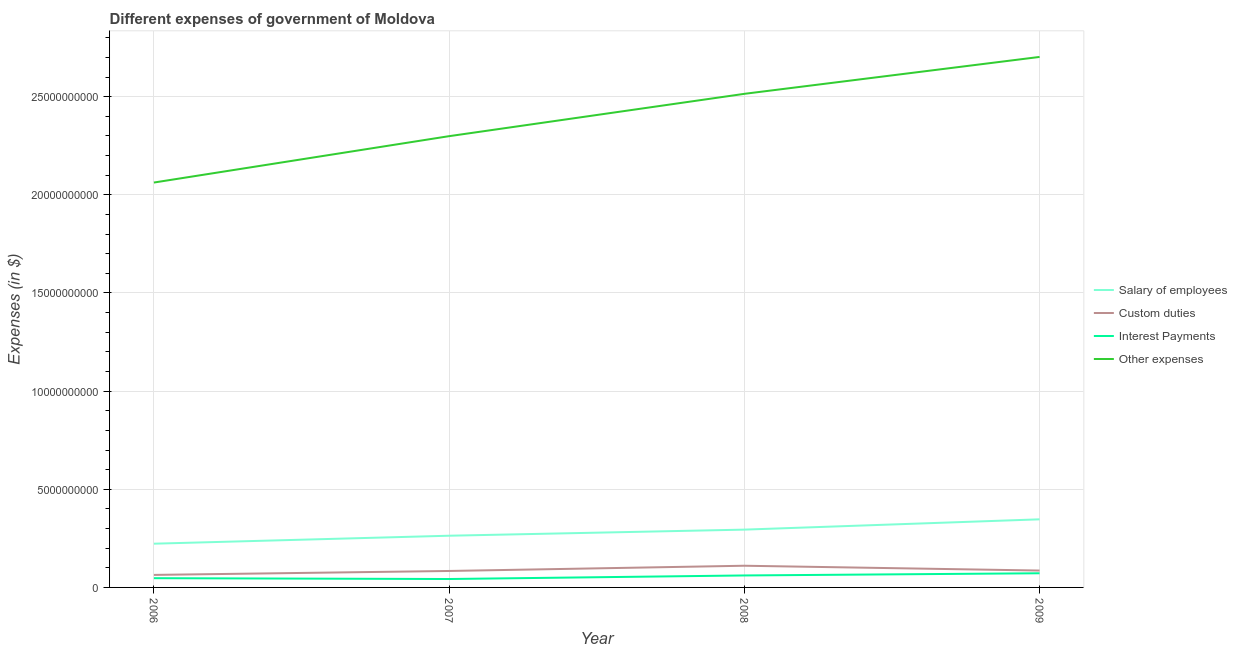How many different coloured lines are there?
Provide a short and direct response. 4. What is the amount spent on custom duties in 2008?
Provide a succinct answer. 1.10e+09. Across all years, what is the maximum amount spent on custom duties?
Make the answer very short. 1.10e+09. Across all years, what is the minimum amount spent on interest payments?
Ensure brevity in your answer.  4.29e+08. What is the total amount spent on custom duties in the graph?
Provide a succinct answer. 3.44e+09. What is the difference between the amount spent on salary of employees in 2006 and that in 2008?
Provide a succinct answer. -7.17e+08. What is the difference between the amount spent on salary of employees in 2006 and the amount spent on other expenses in 2008?
Your answer should be compact. -2.29e+1. What is the average amount spent on other expenses per year?
Provide a short and direct response. 2.39e+1. In the year 2006, what is the difference between the amount spent on other expenses and amount spent on salary of employees?
Provide a succinct answer. 1.84e+1. What is the ratio of the amount spent on custom duties in 2007 to that in 2009?
Provide a short and direct response. 0.97. Is the difference between the amount spent on other expenses in 2006 and 2008 greater than the difference between the amount spent on custom duties in 2006 and 2008?
Your answer should be very brief. No. What is the difference between the highest and the second highest amount spent on other expenses?
Your response must be concise. 1.88e+09. What is the difference between the highest and the lowest amount spent on custom duties?
Give a very brief answer. 4.68e+08. In how many years, is the amount spent on salary of employees greater than the average amount spent on salary of employees taken over all years?
Make the answer very short. 2. Is the sum of the amount spent on other expenses in 2006 and 2007 greater than the maximum amount spent on interest payments across all years?
Ensure brevity in your answer.  Yes. Is it the case that in every year, the sum of the amount spent on other expenses and amount spent on salary of employees is greater than the sum of amount spent on custom duties and amount spent on interest payments?
Provide a short and direct response. Yes. Is it the case that in every year, the sum of the amount spent on salary of employees and amount spent on custom duties is greater than the amount spent on interest payments?
Provide a succinct answer. Yes. Is the amount spent on salary of employees strictly greater than the amount spent on interest payments over the years?
Ensure brevity in your answer.  Yes. Is the amount spent on interest payments strictly less than the amount spent on custom duties over the years?
Offer a very short reply. Yes. What is the difference between two consecutive major ticks on the Y-axis?
Offer a terse response. 5.00e+09. Does the graph contain any zero values?
Offer a terse response. No. How are the legend labels stacked?
Keep it short and to the point. Vertical. What is the title of the graph?
Your answer should be compact. Different expenses of government of Moldova. What is the label or title of the X-axis?
Provide a succinct answer. Year. What is the label or title of the Y-axis?
Offer a very short reply. Expenses (in $). What is the Expenses (in $) in Salary of employees in 2006?
Your response must be concise. 2.23e+09. What is the Expenses (in $) in Custom duties in 2006?
Your answer should be compact. 6.37e+08. What is the Expenses (in $) in Interest Payments in 2006?
Ensure brevity in your answer.  4.70e+08. What is the Expenses (in $) in Other expenses in 2006?
Ensure brevity in your answer.  2.06e+1. What is the Expenses (in $) of Salary of employees in 2007?
Your response must be concise. 2.63e+09. What is the Expenses (in $) of Custom duties in 2007?
Keep it short and to the point. 8.38e+08. What is the Expenses (in $) in Interest Payments in 2007?
Your answer should be compact. 4.29e+08. What is the Expenses (in $) of Other expenses in 2007?
Offer a terse response. 2.30e+1. What is the Expenses (in $) in Salary of employees in 2008?
Ensure brevity in your answer.  2.94e+09. What is the Expenses (in $) in Custom duties in 2008?
Give a very brief answer. 1.10e+09. What is the Expenses (in $) in Interest Payments in 2008?
Your answer should be compact. 6.10e+08. What is the Expenses (in $) of Other expenses in 2008?
Offer a very short reply. 2.51e+1. What is the Expenses (in $) of Salary of employees in 2009?
Provide a short and direct response. 3.47e+09. What is the Expenses (in $) of Custom duties in 2009?
Provide a succinct answer. 8.60e+08. What is the Expenses (in $) in Interest Payments in 2009?
Provide a short and direct response. 7.22e+08. What is the Expenses (in $) of Other expenses in 2009?
Provide a succinct answer. 2.70e+1. Across all years, what is the maximum Expenses (in $) of Salary of employees?
Your answer should be compact. 3.47e+09. Across all years, what is the maximum Expenses (in $) in Custom duties?
Provide a short and direct response. 1.10e+09. Across all years, what is the maximum Expenses (in $) of Interest Payments?
Your answer should be very brief. 7.22e+08. Across all years, what is the maximum Expenses (in $) in Other expenses?
Offer a terse response. 2.70e+1. Across all years, what is the minimum Expenses (in $) of Salary of employees?
Offer a very short reply. 2.23e+09. Across all years, what is the minimum Expenses (in $) in Custom duties?
Your answer should be compact. 6.37e+08. Across all years, what is the minimum Expenses (in $) of Interest Payments?
Offer a terse response. 4.29e+08. Across all years, what is the minimum Expenses (in $) of Other expenses?
Your response must be concise. 2.06e+1. What is the total Expenses (in $) of Salary of employees in the graph?
Your response must be concise. 1.13e+1. What is the total Expenses (in $) in Custom duties in the graph?
Offer a terse response. 3.44e+09. What is the total Expenses (in $) of Interest Payments in the graph?
Give a very brief answer. 2.23e+09. What is the total Expenses (in $) of Other expenses in the graph?
Ensure brevity in your answer.  9.58e+1. What is the difference between the Expenses (in $) of Salary of employees in 2006 and that in 2007?
Give a very brief answer. -4.07e+08. What is the difference between the Expenses (in $) in Custom duties in 2006 and that in 2007?
Your response must be concise. -2.01e+08. What is the difference between the Expenses (in $) in Interest Payments in 2006 and that in 2007?
Provide a succinct answer. 4.19e+07. What is the difference between the Expenses (in $) in Other expenses in 2006 and that in 2007?
Your answer should be compact. -2.36e+09. What is the difference between the Expenses (in $) in Salary of employees in 2006 and that in 2008?
Ensure brevity in your answer.  -7.17e+08. What is the difference between the Expenses (in $) in Custom duties in 2006 and that in 2008?
Ensure brevity in your answer.  -4.68e+08. What is the difference between the Expenses (in $) of Interest Payments in 2006 and that in 2008?
Offer a terse response. -1.39e+08. What is the difference between the Expenses (in $) of Other expenses in 2006 and that in 2008?
Provide a short and direct response. -4.52e+09. What is the difference between the Expenses (in $) in Salary of employees in 2006 and that in 2009?
Provide a succinct answer. -1.24e+09. What is the difference between the Expenses (in $) in Custom duties in 2006 and that in 2009?
Offer a very short reply. -2.23e+08. What is the difference between the Expenses (in $) of Interest Payments in 2006 and that in 2009?
Provide a succinct answer. -2.51e+08. What is the difference between the Expenses (in $) in Other expenses in 2006 and that in 2009?
Keep it short and to the point. -6.40e+09. What is the difference between the Expenses (in $) of Salary of employees in 2007 and that in 2008?
Your answer should be compact. -3.10e+08. What is the difference between the Expenses (in $) in Custom duties in 2007 and that in 2008?
Your answer should be compact. -2.66e+08. What is the difference between the Expenses (in $) in Interest Payments in 2007 and that in 2008?
Ensure brevity in your answer.  -1.81e+08. What is the difference between the Expenses (in $) of Other expenses in 2007 and that in 2008?
Your response must be concise. -2.16e+09. What is the difference between the Expenses (in $) in Salary of employees in 2007 and that in 2009?
Keep it short and to the point. -8.34e+08. What is the difference between the Expenses (in $) in Custom duties in 2007 and that in 2009?
Ensure brevity in your answer.  -2.17e+07. What is the difference between the Expenses (in $) of Interest Payments in 2007 and that in 2009?
Give a very brief answer. -2.93e+08. What is the difference between the Expenses (in $) in Other expenses in 2007 and that in 2009?
Make the answer very short. -4.04e+09. What is the difference between the Expenses (in $) of Salary of employees in 2008 and that in 2009?
Offer a very short reply. -5.25e+08. What is the difference between the Expenses (in $) in Custom duties in 2008 and that in 2009?
Offer a very short reply. 2.45e+08. What is the difference between the Expenses (in $) of Interest Payments in 2008 and that in 2009?
Make the answer very short. -1.12e+08. What is the difference between the Expenses (in $) of Other expenses in 2008 and that in 2009?
Make the answer very short. -1.88e+09. What is the difference between the Expenses (in $) of Salary of employees in 2006 and the Expenses (in $) of Custom duties in 2007?
Offer a very short reply. 1.39e+09. What is the difference between the Expenses (in $) in Salary of employees in 2006 and the Expenses (in $) in Interest Payments in 2007?
Provide a short and direct response. 1.80e+09. What is the difference between the Expenses (in $) of Salary of employees in 2006 and the Expenses (in $) of Other expenses in 2007?
Offer a terse response. -2.08e+1. What is the difference between the Expenses (in $) of Custom duties in 2006 and the Expenses (in $) of Interest Payments in 2007?
Your answer should be very brief. 2.09e+08. What is the difference between the Expenses (in $) of Custom duties in 2006 and the Expenses (in $) of Other expenses in 2007?
Keep it short and to the point. -2.24e+1. What is the difference between the Expenses (in $) of Interest Payments in 2006 and the Expenses (in $) of Other expenses in 2007?
Your response must be concise. -2.25e+1. What is the difference between the Expenses (in $) of Salary of employees in 2006 and the Expenses (in $) of Custom duties in 2008?
Your answer should be very brief. 1.12e+09. What is the difference between the Expenses (in $) of Salary of employees in 2006 and the Expenses (in $) of Interest Payments in 2008?
Provide a succinct answer. 1.62e+09. What is the difference between the Expenses (in $) in Salary of employees in 2006 and the Expenses (in $) in Other expenses in 2008?
Offer a terse response. -2.29e+1. What is the difference between the Expenses (in $) of Custom duties in 2006 and the Expenses (in $) of Interest Payments in 2008?
Give a very brief answer. 2.76e+07. What is the difference between the Expenses (in $) of Custom duties in 2006 and the Expenses (in $) of Other expenses in 2008?
Make the answer very short. -2.45e+1. What is the difference between the Expenses (in $) of Interest Payments in 2006 and the Expenses (in $) of Other expenses in 2008?
Make the answer very short. -2.47e+1. What is the difference between the Expenses (in $) of Salary of employees in 2006 and the Expenses (in $) of Custom duties in 2009?
Keep it short and to the point. 1.37e+09. What is the difference between the Expenses (in $) of Salary of employees in 2006 and the Expenses (in $) of Interest Payments in 2009?
Provide a short and direct response. 1.51e+09. What is the difference between the Expenses (in $) of Salary of employees in 2006 and the Expenses (in $) of Other expenses in 2009?
Your answer should be compact. -2.48e+1. What is the difference between the Expenses (in $) in Custom duties in 2006 and the Expenses (in $) in Interest Payments in 2009?
Provide a short and direct response. -8.42e+07. What is the difference between the Expenses (in $) of Custom duties in 2006 and the Expenses (in $) of Other expenses in 2009?
Keep it short and to the point. -2.64e+1. What is the difference between the Expenses (in $) in Interest Payments in 2006 and the Expenses (in $) in Other expenses in 2009?
Provide a succinct answer. -2.66e+1. What is the difference between the Expenses (in $) of Salary of employees in 2007 and the Expenses (in $) of Custom duties in 2008?
Keep it short and to the point. 1.53e+09. What is the difference between the Expenses (in $) in Salary of employees in 2007 and the Expenses (in $) in Interest Payments in 2008?
Ensure brevity in your answer.  2.02e+09. What is the difference between the Expenses (in $) in Salary of employees in 2007 and the Expenses (in $) in Other expenses in 2008?
Offer a very short reply. -2.25e+1. What is the difference between the Expenses (in $) of Custom duties in 2007 and the Expenses (in $) of Interest Payments in 2008?
Provide a succinct answer. 2.29e+08. What is the difference between the Expenses (in $) in Custom duties in 2007 and the Expenses (in $) in Other expenses in 2008?
Offer a very short reply. -2.43e+1. What is the difference between the Expenses (in $) of Interest Payments in 2007 and the Expenses (in $) of Other expenses in 2008?
Your response must be concise. -2.47e+1. What is the difference between the Expenses (in $) of Salary of employees in 2007 and the Expenses (in $) of Custom duties in 2009?
Your answer should be compact. 1.77e+09. What is the difference between the Expenses (in $) of Salary of employees in 2007 and the Expenses (in $) of Interest Payments in 2009?
Give a very brief answer. 1.91e+09. What is the difference between the Expenses (in $) of Salary of employees in 2007 and the Expenses (in $) of Other expenses in 2009?
Your response must be concise. -2.44e+1. What is the difference between the Expenses (in $) in Custom duties in 2007 and the Expenses (in $) in Interest Payments in 2009?
Ensure brevity in your answer.  1.17e+08. What is the difference between the Expenses (in $) in Custom duties in 2007 and the Expenses (in $) in Other expenses in 2009?
Give a very brief answer. -2.62e+1. What is the difference between the Expenses (in $) in Interest Payments in 2007 and the Expenses (in $) in Other expenses in 2009?
Provide a short and direct response. -2.66e+1. What is the difference between the Expenses (in $) in Salary of employees in 2008 and the Expenses (in $) in Custom duties in 2009?
Offer a terse response. 2.08e+09. What is the difference between the Expenses (in $) of Salary of employees in 2008 and the Expenses (in $) of Interest Payments in 2009?
Provide a short and direct response. 2.22e+09. What is the difference between the Expenses (in $) of Salary of employees in 2008 and the Expenses (in $) of Other expenses in 2009?
Your response must be concise. -2.41e+1. What is the difference between the Expenses (in $) in Custom duties in 2008 and the Expenses (in $) in Interest Payments in 2009?
Your answer should be very brief. 3.83e+08. What is the difference between the Expenses (in $) of Custom duties in 2008 and the Expenses (in $) of Other expenses in 2009?
Keep it short and to the point. -2.59e+1. What is the difference between the Expenses (in $) in Interest Payments in 2008 and the Expenses (in $) in Other expenses in 2009?
Offer a terse response. -2.64e+1. What is the average Expenses (in $) of Salary of employees per year?
Your answer should be very brief. 2.82e+09. What is the average Expenses (in $) of Custom duties per year?
Provide a short and direct response. 8.60e+08. What is the average Expenses (in $) in Interest Payments per year?
Offer a very short reply. 5.58e+08. What is the average Expenses (in $) in Other expenses per year?
Your answer should be very brief. 2.39e+1. In the year 2006, what is the difference between the Expenses (in $) of Salary of employees and Expenses (in $) of Custom duties?
Your response must be concise. 1.59e+09. In the year 2006, what is the difference between the Expenses (in $) of Salary of employees and Expenses (in $) of Interest Payments?
Give a very brief answer. 1.76e+09. In the year 2006, what is the difference between the Expenses (in $) in Salary of employees and Expenses (in $) in Other expenses?
Your answer should be compact. -1.84e+1. In the year 2006, what is the difference between the Expenses (in $) in Custom duties and Expenses (in $) in Interest Payments?
Offer a very short reply. 1.67e+08. In the year 2006, what is the difference between the Expenses (in $) of Custom duties and Expenses (in $) of Other expenses?
Ensure brevity in your answer.  -2.00e+1. In the year 2006, what is the difference between the Expenses (in $) of Interest Payments and Expenses (in $) of Other expenses?
Ensure brevity in your answer.  -2.02e+1. In the year 2007, what is the difference between the Expenses (in $) in Salary of employees and Expenses (in $) in Custom duties?
Give a very brief answer. 1.80e+09. In the year 2007, what is the difference between the Expenses (in $) of Salary of employees and Expenses (in $) of Interest Payments?
Your response must be concise. 2.21e+09. In the year 2007, what is the difference between the Expenses (in $) in Salary of employees and Expenses (in $) in Other expenses?
Provide a succinct answer. -2.04e+1. In the year 2007, what is the difference between the Expenses (in $) in Custom duties and Expenses (in $) in Interest Payments?
Your response must be concise. 4.10e+08. In the year 2007, what is the difference between the Expenses (in $) of Custom duties and Expenses (in $) of Other expenses?
Your answer should be very brief. -2.21e+1. In the year 2007, what is the difference between the Expenses (in $) of Interest Payments and Expenses (in $) of Other expenses?
Provide a short and direct response. -2.26e+1. In the year 2008, what is the difference between the Expenses (in $) of Salary of employees and Expenses (in $) of Custom duties?
Provide a succinct answer. 1.84e+09. In the year 2008, what is the difference between the Expenses (in $) in Salary of employees and Expenses (in $) in Interest Payments?
Provide a succinct answer. 2.33e+09. In the year 2008, what is the difference between the Expenses (in $) in Salary of employees and Expenses (in $) in Other expenses?
Provide a short and direct response. -2.22e+1. In the year 2008, what is the difference between the Expenses (in $) in Custom duties and Expenses (in $) in Interest Payments?
Your answer should be very brief. 4.95e+08. In the year 2008, what is the difference between the Expenses (in $) of Custom duties and Expenses (in $) of Other expenses?
Your answer should be very brief. -2.40e+1. In the year 2008, what is the difference between the Expenses (in $) in Interest Payments and Expenses (in $) in Other expenses?
Offer a very short reply. -2.45e+1. In the year 2009, what is the difference between the Expenses (in $) in Salary of employees and Expenses (in $) in Custom duties?
Ensure brevity in your answer.  2.61e+09. In the year 2009, what is the difference between the Expenses (in $) of Salary of employees and Expenses (in $) of Interest Payments?
Provide a short and direct response. 2.75e+09. In the year 2009, what is the difference between the Expenses (in $) in Salary of employees and Expenses (in $) in Other expenses?
Give a very brief answer. -2.36e+1. In the year 2009, what is the difference between the Expenses (in $) of Custom duties and Expenses (in $) of Interest Payments?
Keep it short and to the point. 1.39e+08. In the year 2009, what is the difference between the Expenses (in $) of Custom duties and Expenses (in $) of Other expenses?
Provide a short and direct response. -2.62e+1. In the year 2009, what is the difference between the Expenses (in $) of Interest Payments and Expenses (in $) of Other expenses?
Give a very brief answer. -2.63e+1. What is the ratio of the Expenses (in $) in Salary of employees in 2006 to that in 2007?
Your answer should be compact. 0.85. What is the ratio of the Expenses (in $) in Custom duties in 2006 to that in 2007?
Provide a short and direct response. 0.76. What is the ratio of the Expenses (in $) in Interest Payments in 2006 to that in 2007?
Give a very brief answer. 1.1. What is the ratio of the Expenses (in $) in Other expenses in 2006 to that in 2007?
Your answer should be very brief. 0.9. What is the ratio of the Expenses (in $) in Salary of employees in 2006 to that in 2008?
Your answer should be compact. 0.76. What is the ratio of the Expenses (in $) of Custom duties in 2006 to that in 2008?
Ensure brevity in your answer.  0.58. What is the ratio of the Expenses (in $) in Interest Payments in 2006 to that in 2008?
Offer a very short reply. 0.77. What is the ratio of the Expenses (in $) of Other expenses in 2006 to that in 2008?
Give a very brief answer. 0.82. What is the ratio of the Expenses (in $) of Salary of employees in 2006 to that in 2009?
Your answer should be compact. 0.64. What is the ratio of the Expenses (in $) in Custom duties in 2006 to that in 2009?
Offer a very short reply. 0.74. What is the ratio of the Expenses (in $) in Interest Payments in 2006 to that in 2009?
Provide a short and direct response. 0.65. What is the ratio of the Expenses (in $) of Other expenses in 2006 to that in 2009?
Keep it short and to the point. 0.76. What is the ratio of the Expenses (in $) of Salary of employees in 2007 to that in 2008?
Offer a very short reply. 0.89. What is the ratio of the Expenses (in $) in Custom duties in 2007 to that in 2008?
Offer a terse response. 0.76. What is the ratio of the Expenses (in $) in Interest Payments in 2007 to that in 2008?
Your response must be concise. 0.7. What is the ratio of the Expenses (in $) of Other expenses in 2007 to that in 2008?
Provide a short and direct response. 0.91. What is the ratio of the Expenses (in $) of Salary of employees in 2007 to that in 2009?
Make the answer very short. 0.76. What is the ratio of the Expenses (in $) of Custom duties in 2007 to that in 2009?
Ensure brevity in your answer.  0.97. What is the ratio of the Expenses (in $) of Interest Payments in 2007 to that in 2009?
Make the answer very short. 0.59. What is the ratio of the Expenses (in $) in Other expenses in 2007 to that in 2009?
Your response must be concise. 0.85. What is the ratio of the Expenses (in $) of Salary of employees in 2008 to that in 2009?
Ensure brevity in your answer.  0.85. What is the ratio of the Expenses (in $) in Custom duties in 2008 to that in 2009?
Provide a short and direct response. 1.28. What is the ratio of the Expenses (in $) in Interest Payments in 2008 to that in 2009?
Offer a terse response. 0.85. What is the ratio of the Expenses (in $) of Other expenses in 2008 to that in 2009?
Ensure brevity in your answer.  0.93. What is the difference between the highest and the second highest Expenses (in $) of Salary of employees?
Make the answer very short. 5.25e+08. What is the difference between the highest and the second highest Expenses (in $) of Custom duties?
Provide a succinct answer. 2.45e+08. What is the difference between the highest and the second highest Expenses (in $) of Interest Payments?
Keep it short and to the point. 1.12e+08. What is the difference between the highest and the second highest Expenses (in $) of Other expenses?
Ensure brevity in your answer.  1.88e+09. What is the difference between the highest and the lowest Expenses (in $) in Salary of employees?
Ensure brevity in your answer.  1.24e+09. What is the difference between the highest and the lowest Expenses (in $) of Custom duties?
Keep it short and to the point. 4.68e+08. What is the difference between the highest and the lowest Expenses (in $) of Interest Payments?
Give a very brief answer. 2.93e+08. What is the difference between the highest and the lowest Expenses (in $) in Other expenses?
Provide a succinct answer. 6.40e+09. 